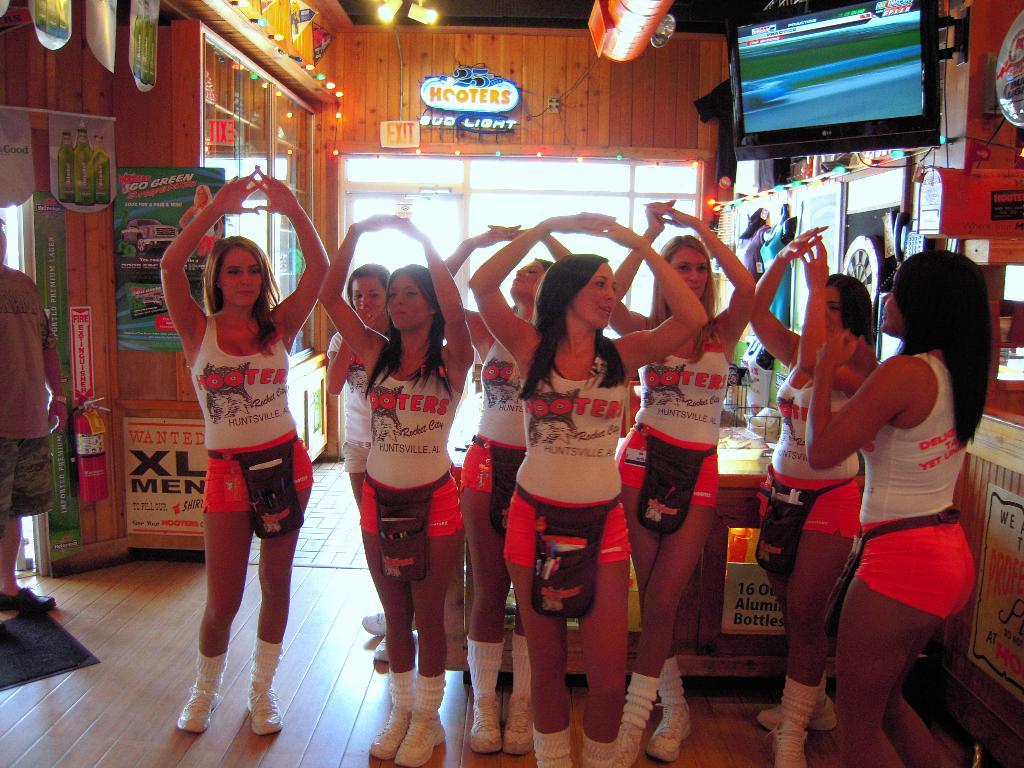What company do these women work for?
Offer a terse response. Hooters. 